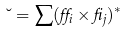Convert formula to latex. <formula><loc_0><loc_0><loc_500><loc_500>\lambda = \sum ( \alpha _ { i } \times \beta _ { j } ) ^ { * }</formula> 